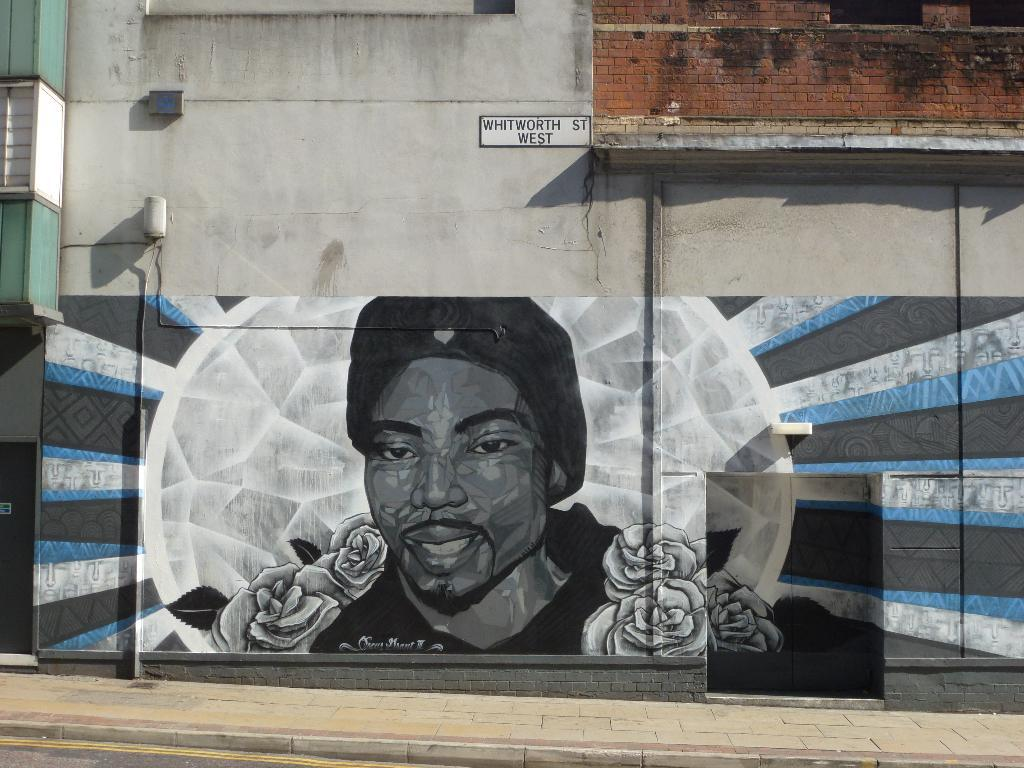What is present on the wall in the image? There is a painting on the wall in the image. What is the surface in front of the wall? There is a pavement in front of the wall. What type of potato is being used as a cast for the broken arm in the image? There is no potato or broken arm present in the image; it only features a wall with a painting and a pavement in front of it. 